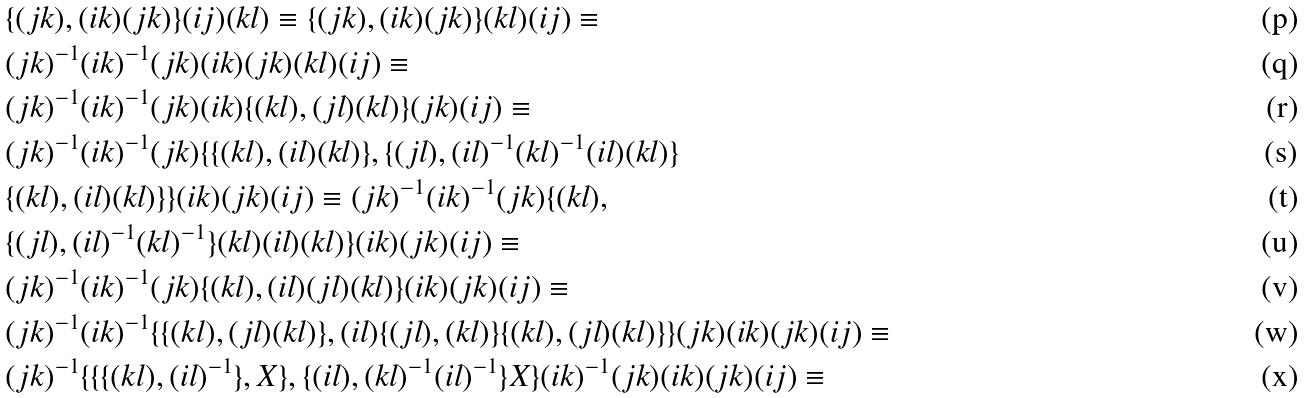Convert formula to latex. <formula><loc_0><loc_0><loc_500><loc_500>& \{ ( j k ) , ( i k ) ( j k ) \} ( i j ) ( k l ) \equiv \{ ( j k ) , ( i k ) ( j k ) \} ( k l ) ( i j ) \equiv \\ & ( j k ) ^ { - 1 } ( i k ) ^ { - 1 } ( j k ) ( i k ) ( j k ) ( k l ) ( i j ) \equiv \\ & ( j k ) ^ { - 1 } ( i k ) ^ { - 1 } ( j k ) ( i k ) \{ ( k l ) , ( j l ) ( k l ) \} ( j k ) ( i j ) \equiv \\ & ( j k ) ^ { - 1 } ( i k ) ^ { - 1 } ( j k ) \{ \{ ( k l ) , ( i l ) ( k l ) \} , \{ ( j l ) , ( i l ) ^ { - 1 } ( k l ) ^ { - 1 } ( i l ) ( k l ) \} \\ & \{ ( k l ) , ( i l ) ( k l ) \} \} ( i k ) ( j k ) ( i j ) \equiv ( j k ) ^ { - 1 } ( i k ) ^ { - 1 } ( j k ) \{ ( k l ) , \\ & \{ ( j l ) , ( i l ) ^ { - 1 } ( k l ) ^ { - 1 } \} ( k l ) ( i l ) ( k l ) \} ( i k ) ( j k ) ( i j ) \equiv \\ & ( j k ) ^ { - 1 } ( i k ) ^ { - 1 } ( j k ) \{ ( k l ) , ( i l ) ( j l ) ( k l ) \} ( i k ) ( j k ) ( i j ) \equiv \\ & ( j k ) ^ { - 1 } ( i k ) ^ { - 1 } \{ \{ ( k l ) , ( j l ) ( k l ) \} , ( i l ) \{ ( j l ) , ( k l ) \} \{ ( k l ) , ( j l ) ( k l ) \} \} ( j k ) ( i k ) ( j k ) ( i j ) \equiv \\ & ( j k ) ^ { - 1 } \{ \{ \{ ( k l ) , ( i l ) ^ { - 1 } \} , X \} , \{ ( i l ) , ( k l ) ^ { - 1 } ( i l ) ^ { - 1 } \} X \} ( i k ) ^ { - 1 } ( j k ) ( i k ) ( j k ) ( i j ) \equiv</formula> 